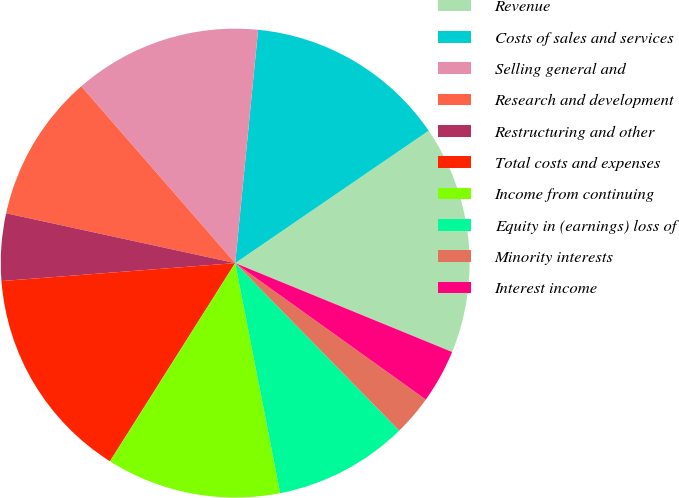<chart> <loc_0><loc_0><loc_500><loc_500><pie_chart><fcel>Revenue<fcel>Costs of sales and services<fcel>Selling general and<fcel>Research and development<fcel>Restructuring and other<fcel>Total costs and expenses<fcel>Income from continuing<fcel>Equity in (earnings) loss of<fcel>Minority interests<fcel>Interest income<nl><fcel>15.74%<fcel>13.89%<fcel>12.96%<fcel>10.19%<fcel>4.63%<fcel>14.81%<fcel>12.04%<fcel>9.26%<fcel>2.78%<fcel>3.7%<nl></chart> 